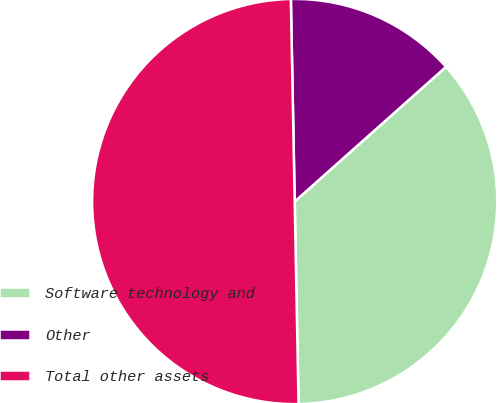<chart> <loc_0><loc_0><loc_500><loc_500><pie_chart><fcel>Software technology and<fcel>Other<fcel>Total other assets<nl><fcel>36.27%<fcel>13.73%<fcel>50.0%<nl></chart> 